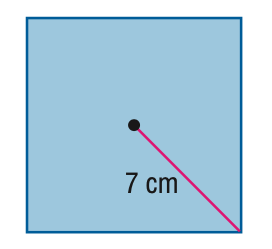Question: Find the area of the regular polygon. Round to the nearest tenth.
Choices:
A. 24.5
B. 49
C. 98
D. 392
Answer with the letter. Answer: C 